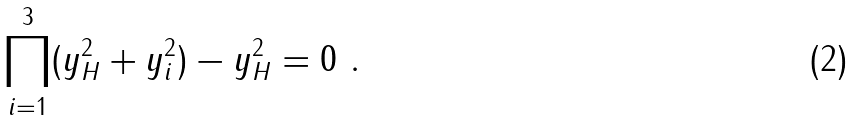Convert formula to latex. <formula><loc_0><loc_0><loc_500><loc_500>\prod _ { i = 1 } ^ { 3 } ( y _ { H } ^ { 2 } + y _ { i } ^ { 2 } ) - y _ { H } ^ { 2 } = 0 \ .</formula> 